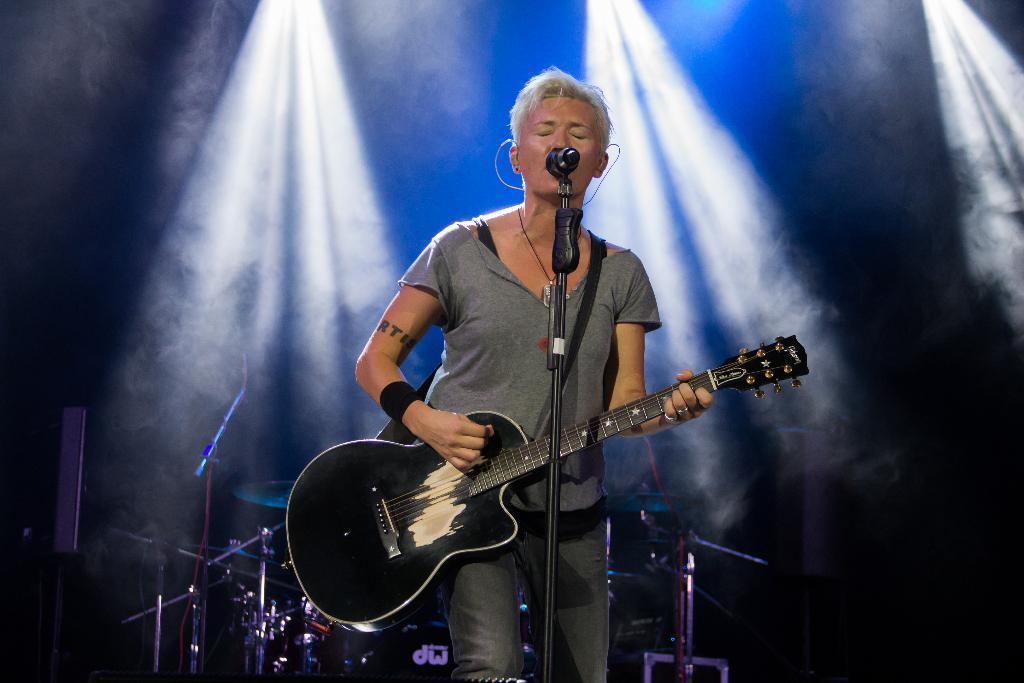What is the woman in the image doing? The woman is singing and playing a guitar. What is the woman using to amplify her voice in the image? There is a microphone in front of the woman. What other musical instruments can be seen in the image? There are musical instruments visible behind the woman. What type of polish is the woman applying to her nails in the image? There is no indication in the image that the woman is applying any polish to her nails. What channel is the woman performing on in the image? The image does not provide any information about a specific channel or performance venue. 